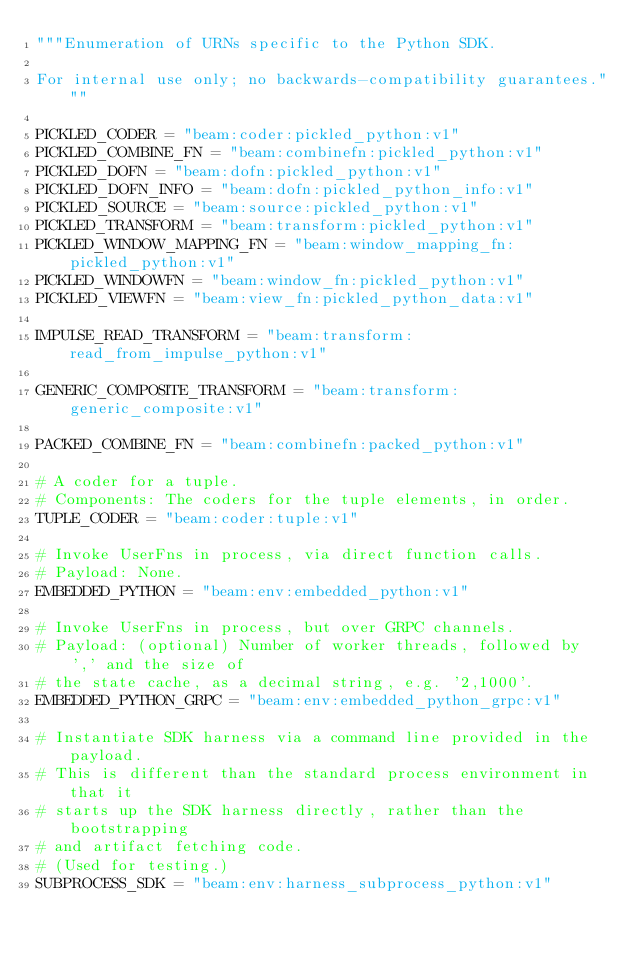Convert code to text. <code><loc_0><loc_0><loc_500><loc_500><_Python_>"""Enumeration of URNs specific to the Python SDK.

For internal use only; no backwards-compatibility guarantees."""

PICKLED_CODER = "beam:coder:pickled_python:v1"
PICKLED_COMBINE_FN = "beam:combinefn:pickled_python:v1"
PICKLED_DOFN = "beam:dofn:pickled_python:v1"
PICKLED_DOFN_INFO = "beam:dofn:pickled_python_info:v1"
PICKLED_SOURCE = "beam:source:pickled_python:v1"
PICKLED_TRANSFORM = "beam:transform:pickled_python:v1"
PICKLED_WINDOW_MAPPING_FN = "beam:window_mapping_fn:pickled_python:v1"
PICKLED_WINDOWFN = "beam:window_fn:pickled_python:v1"
PICKLED_VIEWFN = "beam:view_fn:pickled_python_data:v1"

IMPULSE_READ_TRANSFORM = "beam:transform:read_from_impulse_python:v1"

GENERIC_COMPOSITE_TRANSFORM = "beam:transform:generic_composite:v1"

PACKED_COMBINE_FN = "beam:combinefn:packed_python:v1"

# A coder for a tuple.
# Components: The coders for the tuple elements, in order.
TUPLE_CODER = "beam:coder:tuple:v1"

# Invoke UserFns in process, via direct function calls.
# Payload: None.
EMBEDDED_PYTHON = "beam:env:embedded_python:v1"

# Invoke UserFns in process, but over GRPC channels.
# Payload: (optional) Number of worker threads, followed by ',' and the size of
# the state cache, as a decimal string, e.g. '2,1000'.
EMBEDDED_PYTHON_GRPC = "beam:env:embedded_python_grpc:v1"

# Instantiate SDK harness via a command line provided in the payload.
# This is different than the standard process environment in that it
# starts up the SDK harness directly, rather than the bootstrapping
# and artifact fetching code.
# (Used for testing.)
SUBPROCESS_SDK = "beam:env:harness_subprocess_python:v1"
</code> 